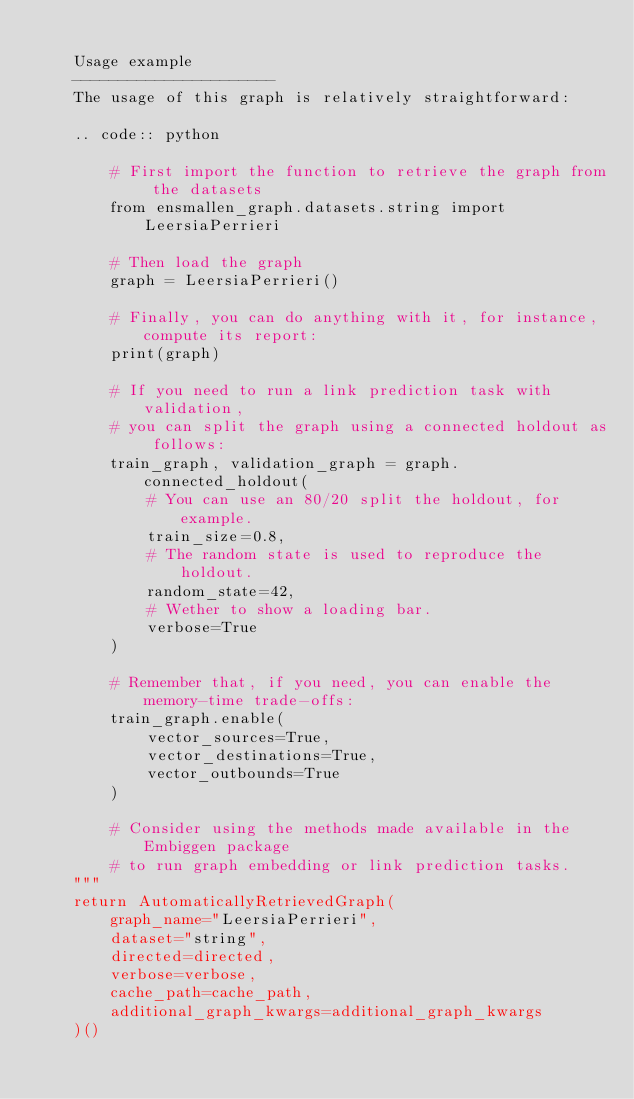Convert code to text. <code><loc_0><loc_0><loc_500><loc_500><_Python_>
	Usage example
	----------------------
	The usage of this graph is relatively straightforward:
	
	.. code:: python
	
	    # First import the function to retrieve the graph from the datasets
	    from ensmallen_graph.datasets.string import LeersiaPerrieri
	
	    # Then load the graph
	    graph = LeersiaPerrieri()
	
	    # Finally, you can do anything with it, for instance, compute its report:
	    print(graph)
	
	    # If you need to run a link prediction task with validation,
	    # you can split the graph using a connected holdout as follows:
	    train_graph, validation_graph = graph.connected_holdout(
	        # You can use an 80/20 split the holdout, for example.
	        train_size=0.8,
	        # The random state is used to reproduce the holdout.
	        random_state=42,
	        # Wether to show a loading bar.
	        verbose=True
	    )
	
	    # Remember that, if you need, you can enable the memory-time trade-offs:
	    train_graph.enable(
	        vector_sources=True,
	        vector_destinations=True,
	        vector_outbounds=True
	    )
	
	    # Consider using the methods made available in the Embiggen package
	    # to run graph embedding or link prediction tasks.
    """
    return AutomaticallyRetrievedGraph(
        graph_name="LeersiaPerrieri",
        dataset="string",
        directed=directed,
        verbose=verbose,
        cache_path=cache_path,
        additional_graph_kwargs=additional_graph_kwargs
    )()
</code> 